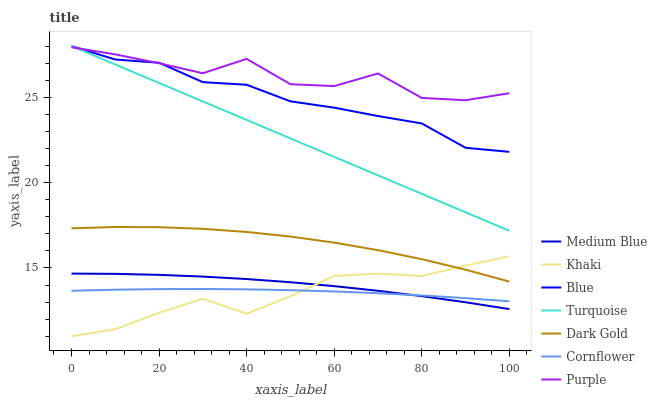Does Khaki have the minimum area under the curve?
Answer yes or no. Yes. Does Purple have the maximum area under the curve?
Answer yes or no. Yes. Does Cornflower have the minimum area under the curve?
Answer yes or no. No. Does Cornflower have the maximum area under the curve?
Answer yes or no. No. Is Turquoise the smoothest?
Answer yes or no. Yes. Is Purple the roughest?
Answer yes or no. Yes. Is Cornflower the smoothest?
Answer yes or no. No. Is Cornflower the roughest?
Answer yes or no. No. Does Cornflower have the lowest value?
Answer yes or no. No. Does Turquoise have the highest value?
Answer yes or no. Yes. Does Cornflower have the highest value?
Answer yes or no. No. Is Medium Blue less than Turquoise?
Answer yes or no. Yes. Is Turquoise greater than Khaki?
Answer yes or no. Yes. Does Turquoise intersect Purple?
Answer yes or no. Yes. Is Turquoise less than Purple?
Answer yes or no. No. Is Turquoise greater than Purple?
Answer yes or no. No. Does Medium Blue intersect Turquoise?
Answer yes or no. No. 